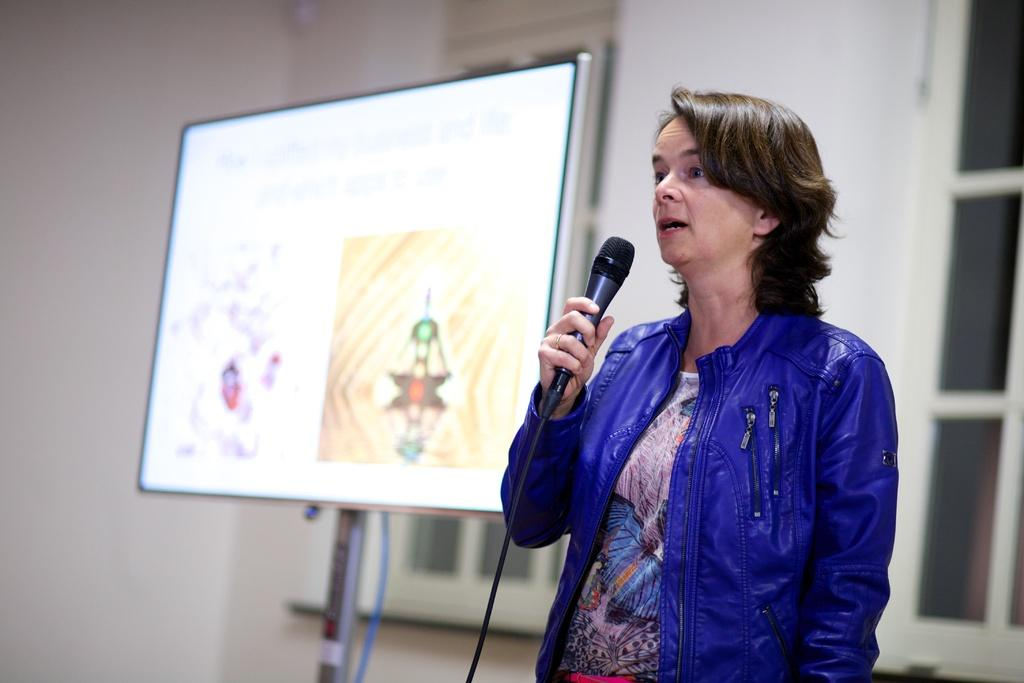Who is the main subject in the image? There is a woman in the image. What is the woman holding in her hand? The woman is holding a microphone in her hand. What can be seen on the pole in the image? There is a screen on a pole in the image. What is visible in the background of the image? There are windows and a wall visible in the background of the image. What is the size of the vein in the woman's hand? There is no visible vein in the woman's hand in the image, so it is not possible to determine its size. 